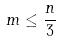<formula> <loc_0><loc_0><loc_500><loc_500>m \leq \frac { n } { 3 }</formula> 